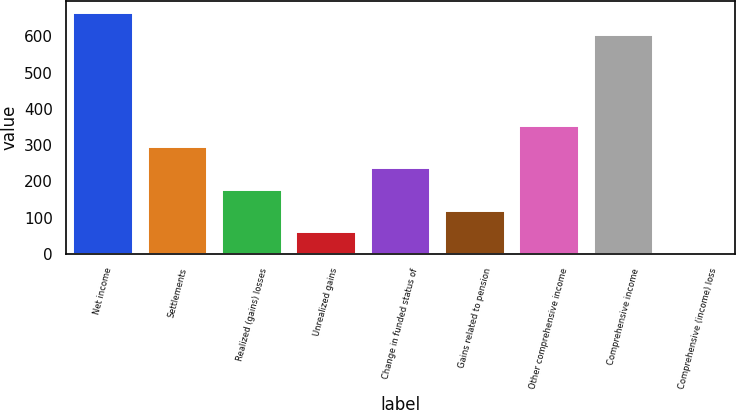Convert chart to OTSL. <chart><loc_0><loc_0><loc_500><loc_500><bar_chart><fcel>Net income<fcel>Settlements<fcel>Realized (gains) losses<fcel>Unrealized gains<fcel>Change in funded status of<fcel>Gains related to pension<fcel>Other comprehensive income<fcel>Comprehensive income<fcel>Comprehensive (income) loss<nl><fcel>663.22<fcel>294.6<fcel>176.88<fcel>59.16<fcel>235.74<fcel>118.02<fcel>353.46<fcel>604.36<fcel>0.3<nl></chart> 